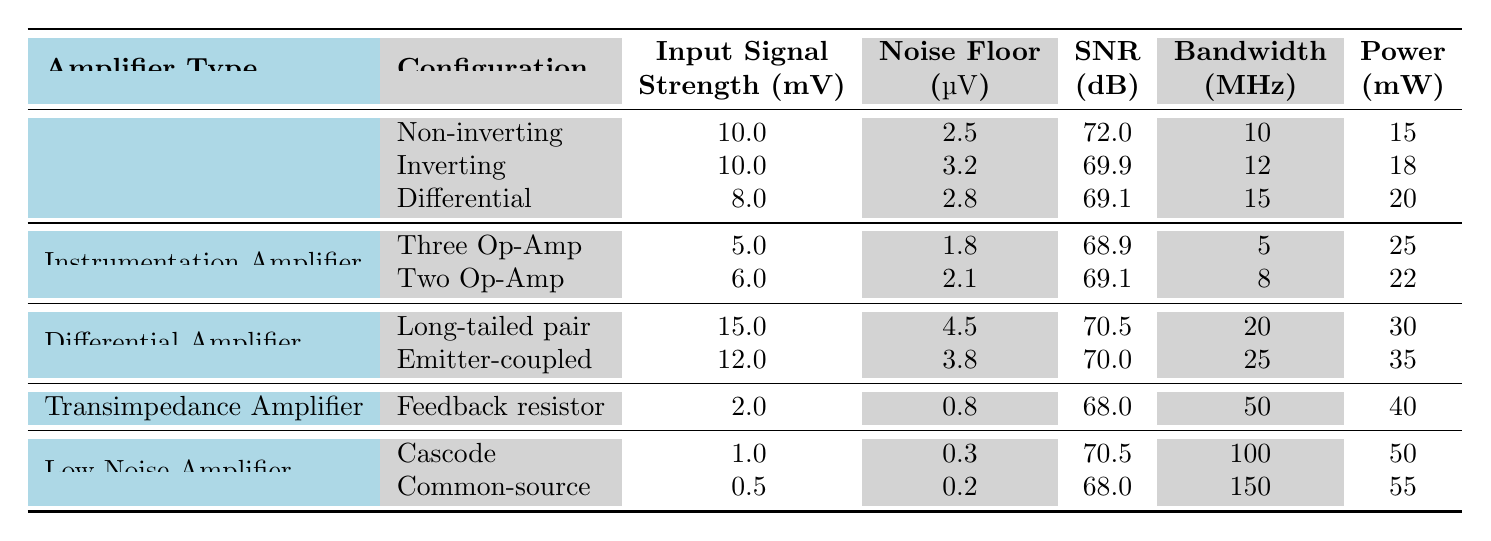What is the signal-to-noise ratio for the Low Noise Amplifier in Cascode configuration? In the table, under the Low Noise Amplifier section, for the Cascode configuration, the SNR value is listed as 70.5 dB.
Answer: 70.5 dB Which configuration has the highest input signal strength? Reviewing the input signal strength values across all configurations, the Long-tailed pair configuration of the Differential Amplifier has the highest strength at 15 mV.
Answer: 15 mV What is the average power consumption of the Operational Amplifier configurations? The Operational Amplifier configurations have power consumptions of 15 mW, 18 mW, and 20 mW. The average power is calculated as (15 + 18 + 20) / 3 = 17.67 mW.
Answer: 17.67 mW Is the noise floor for the Transimpedance Amplifier lower than that of the Long-tailed pair configuration? The noise floor for the Transimpedance Amplifier is 0.8 µV, while the Long-tailed pair configuration shows a noise floor of 4.5 µV, meaning the Transimpedance Amplifier has a lower noise floor.
Answer: Yes Which amplifier configuration has the highest bandwidth? Looking at the bandwidth values in the table, the Common-source configuration for the Low Noise Amplifier has the highest bandwidth at 150 MHz.
Answer: 150 MHz What is the difference in signal-to-noise ratio between the Non-inverting and Inverting configurations of the Operational Amplifier? The Non-inverting configuration has an SNR of 72.0 dB and the Inverting configuration has 69.9 dB. The difference is calculated as 72.0 - 69.9 = 2.1 dB.
Answer: 2.1 dB Are all configurations of the Low Noise Amplifier's SNR values above 68 dB? The Cascode configuration has an SNR of 70.5 dB and the Common-source configuration has 68.0 dB. Therefore, not all SNR values are above 68 dB because the Common-source is exactly 68 dB.
Answer: No Which type of amplifier configuration has the lowest noise floor? The table indicates that the Common-source configuration of the Low Noise Amplifier has the lowest noise floor at 0.2 µV.
Answer: 0.2 µV 